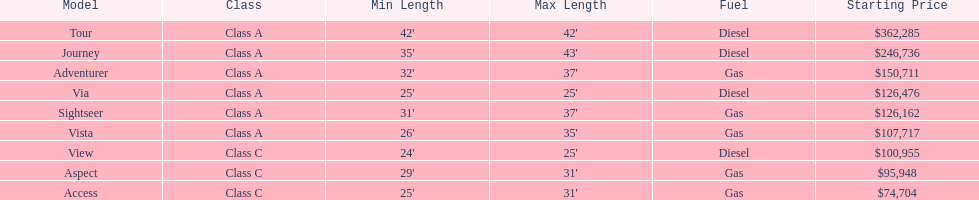Which model has the lowest started price? Access. 